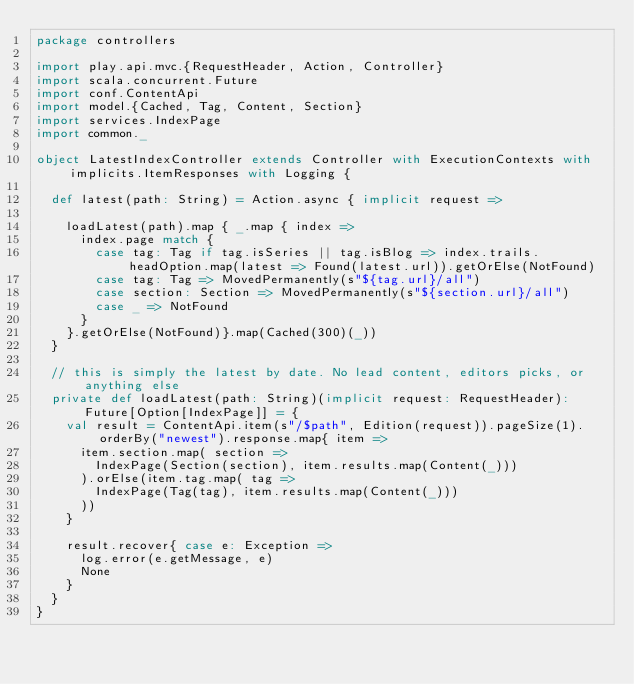<code> <loc_0><loc_0><loc_500><loc_500><_Scala_>package controllers

import play.api.mvc.{RequestHeader, Action, Controller}
import scala.concurrent.Future
import conf.ContentApi
import model.{Cached, Tag, Content, Section}
import services.IndexPage
import common._

object LatestIndexController extends Controller with ExecutionContexts with implicits.ItemResponses with Logging {

  def latest(path: String) = Action.async { implicit request =>

    loadLatest(path).map { _.map { index =>
      index.page match {
        case tag: Tag if tag.isSeries || tag.isBlog => index.trails.headOption.map(latest => Found(latest.url)).getOrElse(NotFound)
        case tag: Tag => MovedPermanently(s"${tag.url}/all")
        case section: Section => MovedPermanently(s"${section.url}/all")
        case _ => NotFound
      }
    }.getOrElse(NotFound)}.map(Cached(300)(_))
  }

  // this is simply the latest by date. No lead content, editors picks, or anything else
  private def loadLatest(path: String)(implicit request: RequestHeader): Future[Option[IndexPage]] = {
    val result = ContentApi.item(s"/$path", Edition(request)).pageSize(1).orderBy("newest").response.map{ item =>
      item.section.map( section =>
        IndexPage(Section(section), item.results.map(Content(_)))
      ).orElse(item.tag.map( tag =>
        IndexPage(Tag(tag), item.results.map(Content(_)))
      ))
    }

    result.recover{ case e: Exception =>
      log.error(e.getMessage, e)
      None
    }
  }
}
</code> 